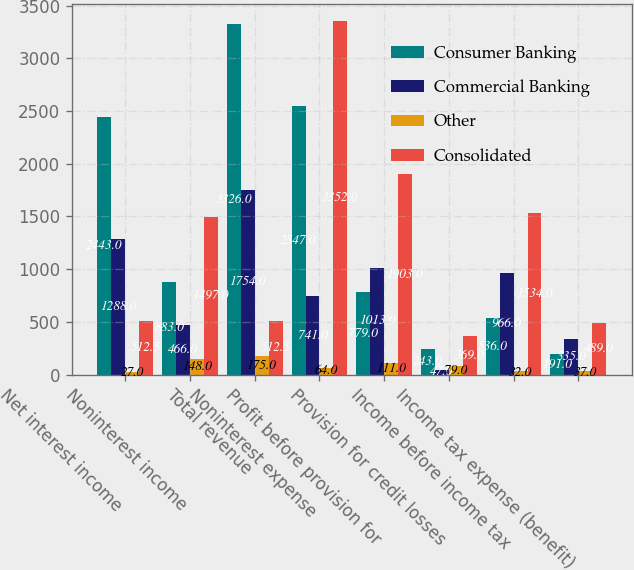Convert chart to OTSL. <chart><loc_0><loc_0><loc_500><loc_500><stacked_bar_chart><ecel><fcel>Net interest income<fcel>Noninterest income<fcel>Total revenue<fcel>Noninterest expense<fcel>Profit before provision for<fcel>Provision for credit losses<fcel>Income before income tax<fcel>Income tax expense (benefit)<nl><fcel>Consumer Banking<fcel>2443<fcel>883<fcel>3326<fcel>2547<fcel>779<fcel>243<fcel>536<fcel>191<nl><fcel>Commercial Banking<fcel>1288<fcel>466<fcel>1754<fcel>741<fcel>1013<fcel>47<fcel>966<fcel>335<nl><fcel>Other<fcel>27<fcel>148<fcel>175<fcel>64<fcel>111<fcel>79<fcel>32<fcel>37<nl><fcel>Consolidated<fcel>512.5<fcel>1497<fcel>512.5<fcel>3352<fcel>1903<fcel>369<fcel>1534<fcel>489<nl></chart> 